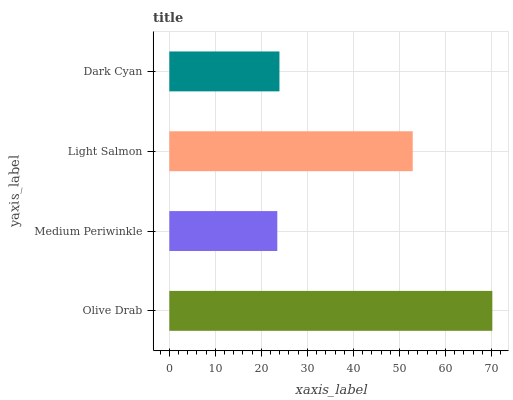Is Medium Periwinkle the minimum?
Answer yes or no. Yes. Is Olive Drab the maximum?
Answer yes or no. Yes. Is Light Salmon the minimum?
Answer yes or no. No. Is Light Salmon the maximum?
Answer yes or no. No. Is Light Salmon greater than Medium Periwinkle?
Answer yes or no. Yes. Is Medium Periwinkle less than Light Salmon?
Answer yes or no. Yes. Is Medium Periwinkle greater than Light Salmon?
Answer yes or no. No. Is Light Salmon less than Medium Periwinkle?
Answer yes or no. No. Is Light Salmon the high median?
Answer yes or no. Yes. Is Dark Cyan the low median?
Answer yes or no. Yes. Is Dark Cyan the high median?
Answer yes or no. No. Is Olive Drab the low median?
Answer yes or no. No. 